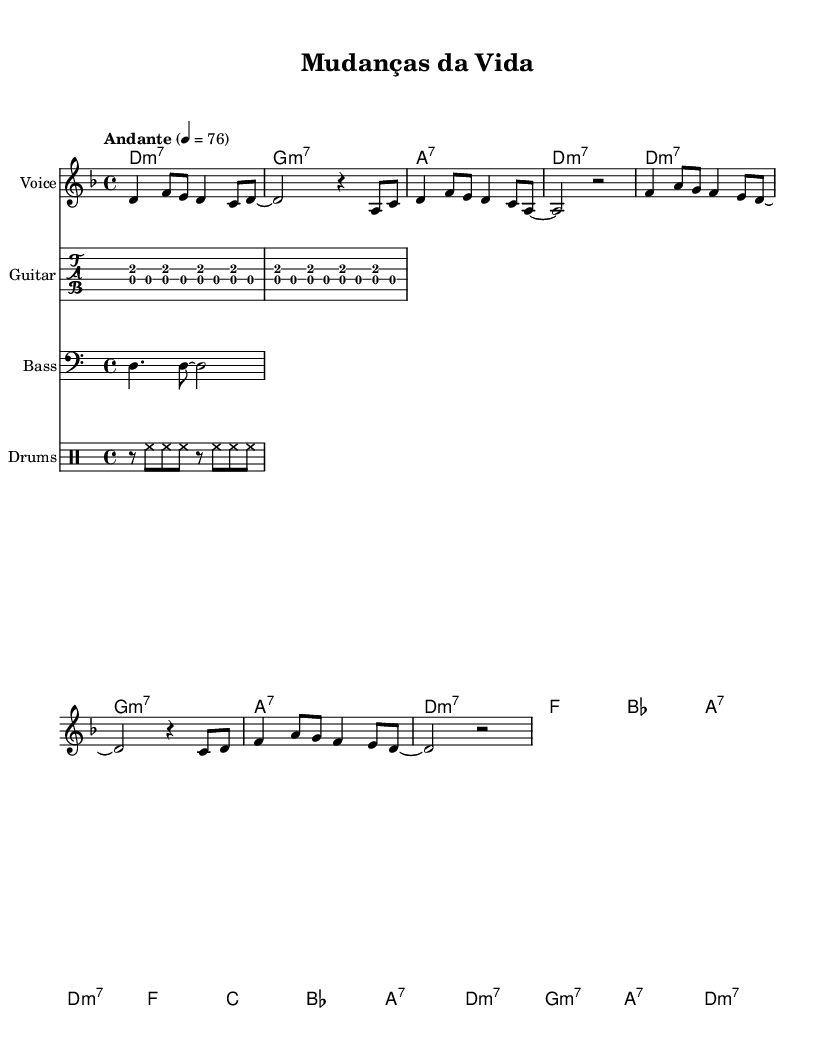What is the key signature of this music? The key signature is D minor, which contains one flat (B flat). It is indicated at the beginning of the staff in the key signature section.
Answer: D minor What is the time signature of this composition? The time signature is 4/4, shown at the beginning of the staff. This means there are four beats in each measure and the quarter note gets one beat.
Answer: 4/4 What is the tempo marking for this piece? The tempo marking is "Andante" and a metronome marking of 76 beats per minute. This describes the speed at which the piece should be played, indicating a moderately slow pace.
Answer: Andante 4 = 76 How many measures are in the verse section? The verse section consists of eight measures (four statements of the melody and harmonies), as counted in the provided structure.
Answer: 8 What chord follows A7 in the chorus? In the chorus, the chord that follows A7 is D minor 7, indicated in the chord progression below the melody line. This is part of the harmonic structure highlighting the relationship between the chords.
Answer: D minor 7 What musical style does this piece represent? This piece represents the style of Bossa Nova, which is characterized by its combination of samba and jazz influences, often reflecting on life's unexpected turns. The syncopated rhythms and harmonies also contribute to this genre.
Answer: Bossa Nova 